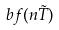<formula> <loc_0><loc_0><loc_500><loc_500>b f ( n \tilde { T } )</formula> 